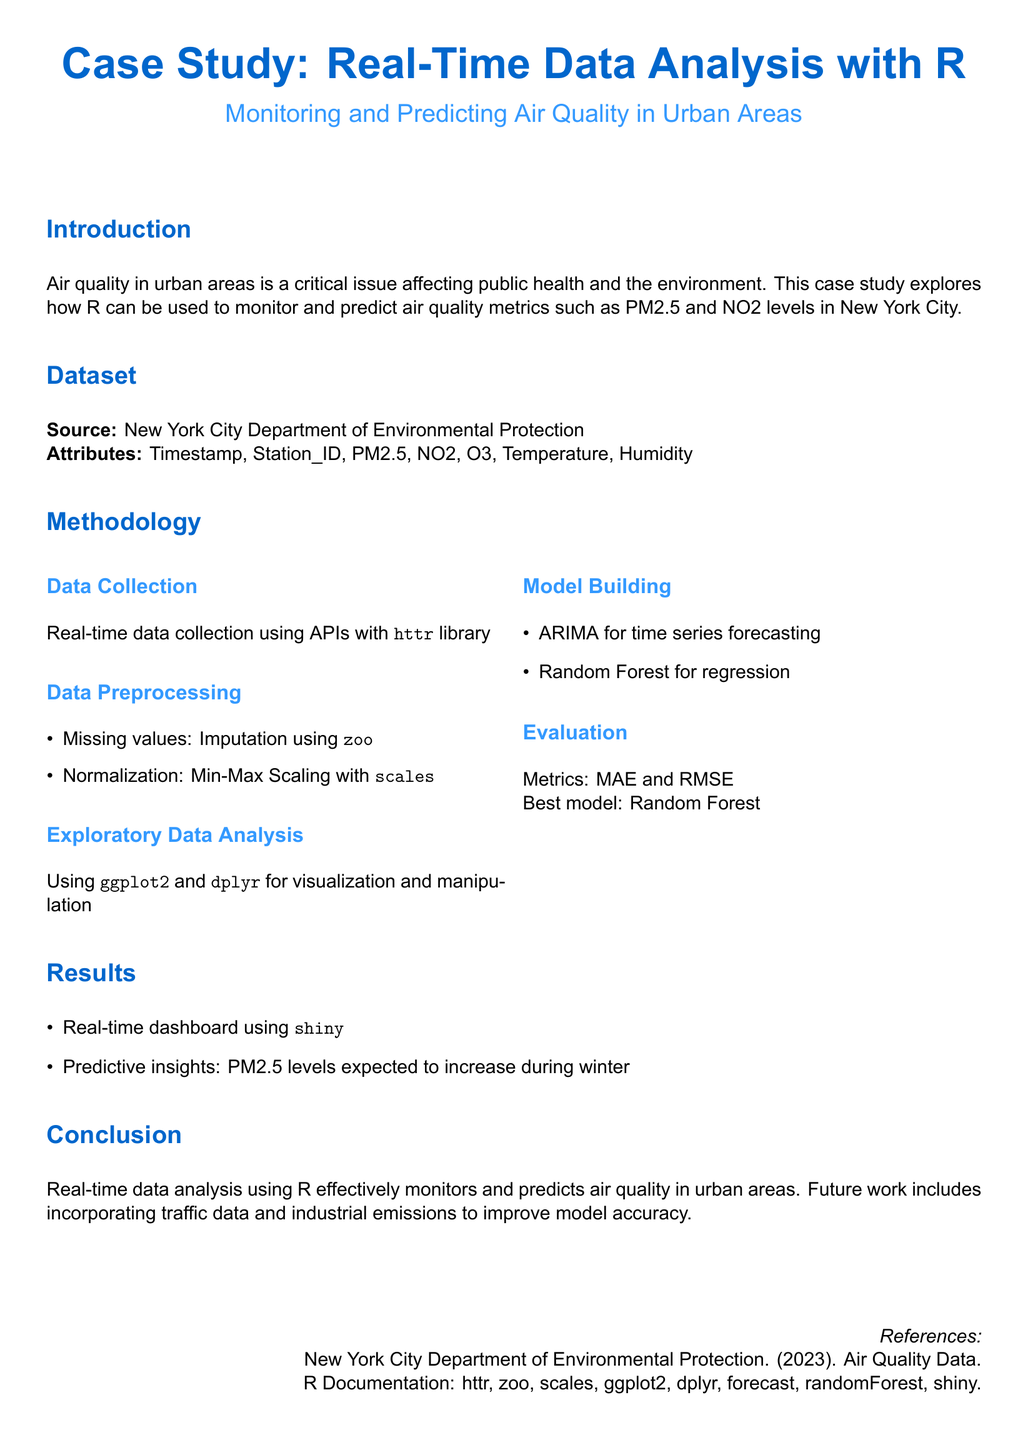what is the primary focus of the case study? The primary focus of the case study is to explore how R can be used to monitor and predict air quality metrics in urban areas.
Answer: monitoring and predicting air quality who is the data source for the study? The data source for the study is mentioned in the dataset section of the document.
Answer: New York City Department of Environmental Protection which two air quality metrics are highlighted in the study? The study highlights two specific air quality metrics in the introduction.
Answer: PM2.5 and NO2 what data collection method is mentioned in the methodology? The methodology section specifies the data collection method used in the study.
Answer: APIs which model was found to be the best for prediction? The evaluation section indicates the best model used for prediction in the study.
Answer: Random Forest what are the two metrics used for evaluation? The evaluation section lists the specific metrics used to evaluate the models.
Answer: MAE and RMSE what tool was used to create the real-time dashboard? The results section mentions the tool used to create the dashboard.
Answer: shiny what season is associated with expected increases in PM2.5 levels? The results section provides insights related to seasonal changes in PM2.5 levels.
Answer: winter what future work is suggested in the conclusion? The conclusion section indicates an area of improvement for future work in the identified field.
Answer: incorporating traffic data and industrial emissions 